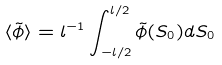<formula> <loc_0><loc_0><loc_500><loc_500>\langle \tilde { \phi } \rangle = l ^ { - 1 } \int _ { - l / 2 } ^ { l / 2 } \tilde { \phi } ( S _ { 0 } ) d S _ { 0 }</formula> 